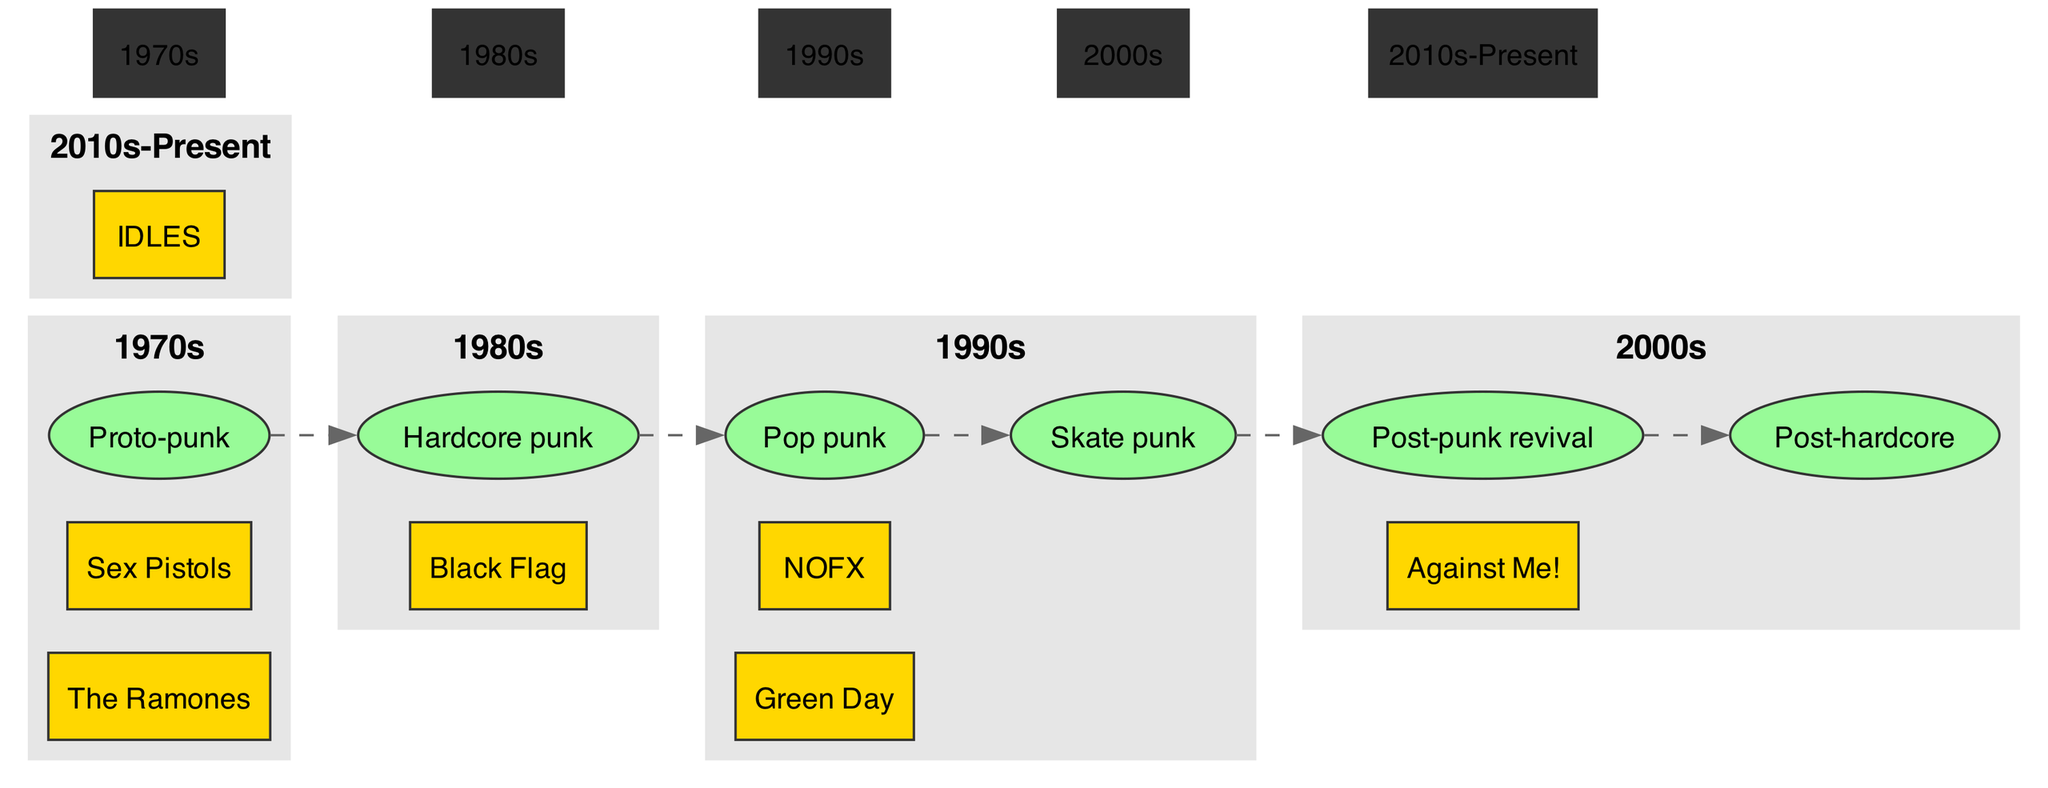What key band is associated with the 1980s? The diagram lists Black Flag as a key band specifically associated with the 1980s, which is clearly marked in the section for that era.
Answer: Black Flag How many key events are represented in the diagram? There are four key events listed within the timeline, identified by their respective nodes, which can be counted directly from the diagram.
Answer: 4 Which subgenre first appeared in the 1990s? The diagram indicates two subgenres that emerged in the 1990s: Pop punk and Skate punk, noted in their respective nodes under that era heading.
Answer: Pop punk, Skate punk What year did the Warped Tour begin? The Warped Tour is listed as a key event occurring in 1995, which can be directly referenced from the event node labeled with that name in the 1990s section.
Answer: 1995 Which band is noted for the 2000s era? Against Me! is shown in the diagram as a key band linked to the 2000s, identified clearly in the subgraph for that era.
Answer: Against Me! What was the first key event in the timeline? The first key event, as noted in the 1970s section, is the opening of the CBGB club in 1973, which is depicted among the nodes of that era.
Answer: CBGB club opens What subgenre follows hardcore punk in the timeline? Post-punk revival appears immediately after the Hardcore punk subgenre in the timeline sequence, which can be tracked by following the subgenres listed chronologically.
Answer: Post-punk revival How many key bands are listed in the 1970s? There are two key bands noted in the 1970s, The Ramones and Sex Pistols, which can be counted within the designated area for that decade.
Answer: 2 Which band marks the transition from 1990s to 2000s? The movement from 1990s to 2000s features Against Me!, whose transition is represented in the diagram due to their placement at the beginning of the 2000s section.
Answer: Against Me! 